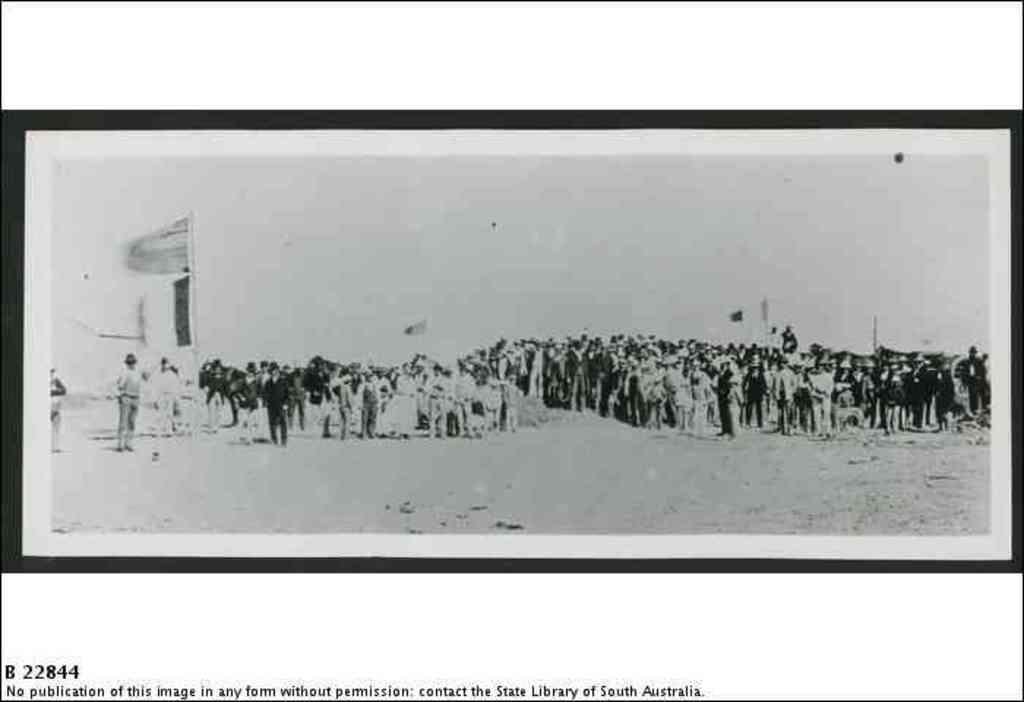<image>
Share a concise interpretation of the image provided. A print from the State Library of Australia shows people and a flag. 